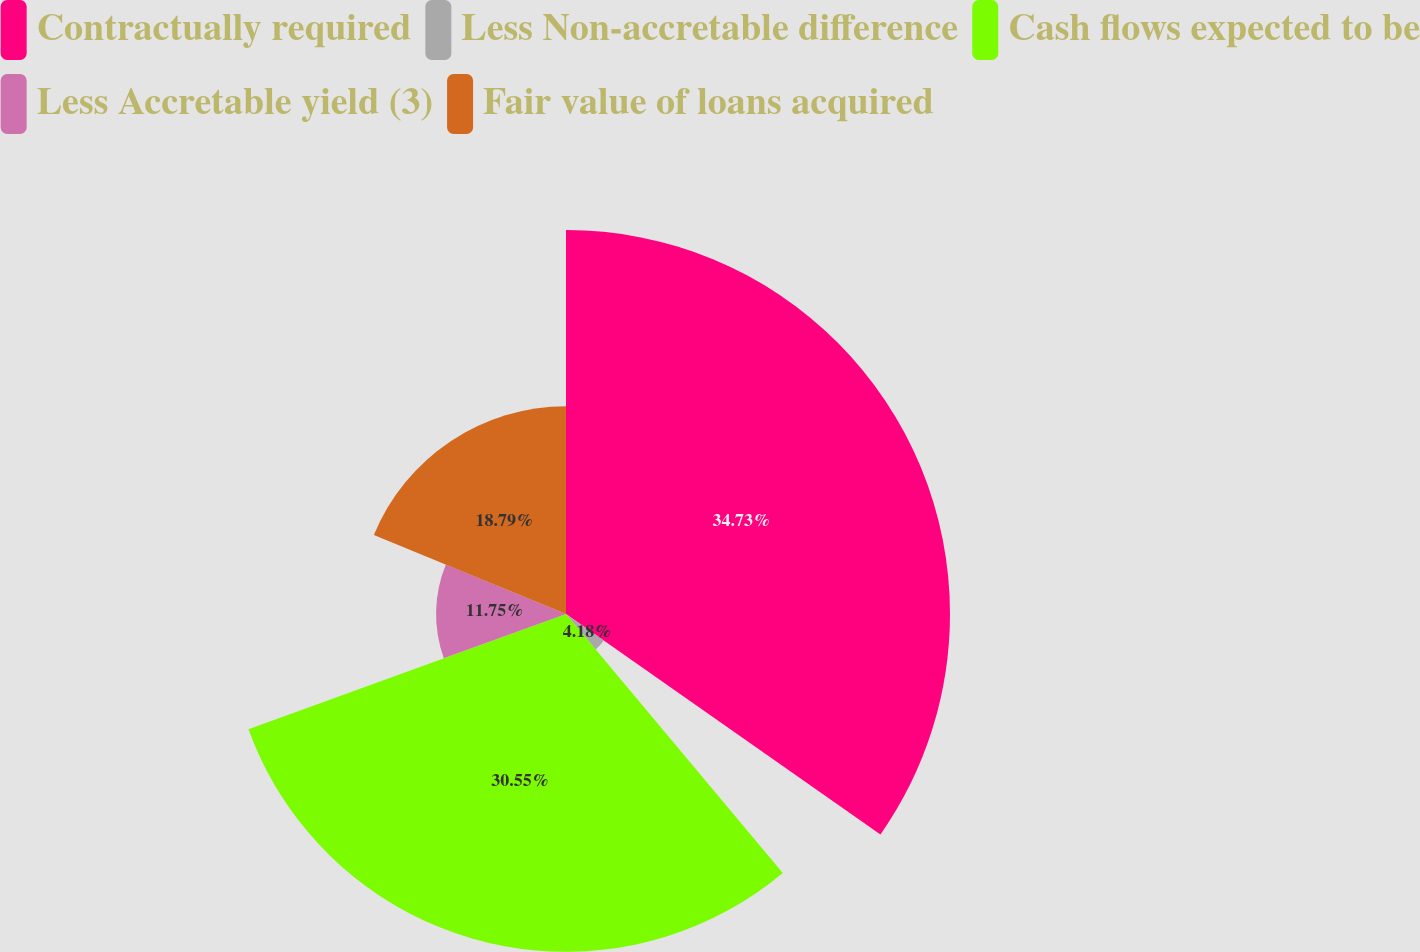<chart> <loc_0><loc_0><loc_500><loc_500><pie_chart><fcel>Contractually required<fcel>Less Non-accretable difference<fcel>Cash flows expected to be<fcel>Less Accretable yield (3)<fcel>Fair value of loans acquired<nl><fcel>34.73%<fcel>4.18%<fcel>30.55%<fcel>11.75%<fcel>18.79%<nl></chart> 